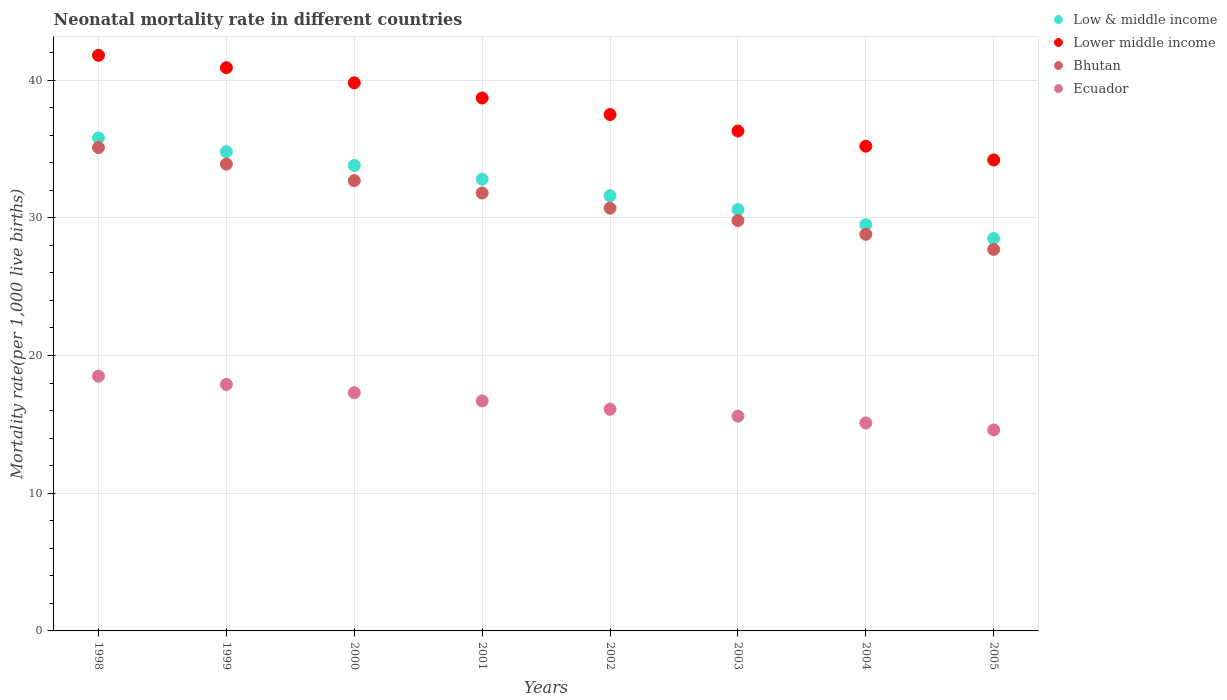Is the number of dotlines equal to the number of legend labels?
Offer a very short reply. Yes. Across all years, what is the maximum neonatal mortality rate in Low & middle income?
Provide a short and direct response. 35.8. In which year was the neonatal mortality rate in Low & middle income minimum?
Your answer should be very brief. 2005. What is the total neonatal mortality rate in Bhutan in the graph?
Provide a short and direct response. 250.5. What is the difference between the neonatal mortality rate in Bhutan in 1998 and that in 1999?
Offer a very short reply. 1.2. What is the difference between the neonatal mortality rate in Bhutan in 2000 and the neonatal mortality rate in Ecuador in 2005?
Keep it short and to the point. 18.1. What is the average neonatal mortality rate in Bhutan per year?
Provide a short and direct response. 31.31. In the year 2004, what is the difference between the neonatal mortality rate in Bhutan and neonatal mortality rate in Ecuador?
Your answer should be compact. 13.7. What is the ratio of the neonatal mortality rate in Bhutan in 1998 to that in 2003?
Offer a terse response. 1.18. What is the difference between the highest and the second highest neonatal mortality rate in Bhutan?
Give a very brief answer. 1.2. What is the difference between the highest and the lowest neonatal mortality rate in Bhutan?
Offer a very short reply. 7.4. In how many years, is the neonatal mortality rate in Ecuador greater than the average neonatal mortality rate in Ecuador taken over all years?
Keep it short and to the point. 4. Is the sum of the neonatal mortality rate in Lower middle income in 2000 and 2004 greater than the maximum neonatal mortality rate in Bhutan across all years?
Your answer should be compact. Yes. Is it the case that in every year, the sum of the neonatal mortality rate in Lower middle income and neonatal mortality rate in Ecuador  is greater than the sum of neonatal mortality rate in Low & middle income and neonatal mortality rate in Bhutan?
Ensure brevity in your answer.  Yes. Is the neonatal mortality rate in Ecuador strictly greater than the neonatal mortality rate in Low & middle income over the years?
Give a very brief answer. No. How many years are there in the graph?
Your response must be concise. 8. What is the difference between two consecutive major ticks on the Y-axis?
Your answer should be compact. 10. Are the values on the major ticks of Y-axis written in scientific E-notation?
Offer a very short reply. No. Does the graph contain grids?
Your answer should be very brief. Yes. Where does the legend appear in the graph?
Keep it short and to the point. Top right. How are the legend labels stacked?
Offer a terse response. Vertical. What is the title of the graph?
Your response must be concise. Neonatal mortality rate in different countries. What is the label or title of the X-axis?
Provide a succinct answer. Years. What is the label or title of the Y-axis?
Your response must be concise. Mortality rate(per 1,0 live births). What is the Mortality rate(per 1,000 live births) of Low & middle income in 1998?
Provide a succinct answer. 35.8. What is the Mortality rate(per 1,000 live births) of Lower middle income in 1998?
Offer a terse response. 41.8. What is the Mortality rate(per 1,000 live births) in Bhutan in 1998?
Give a very brief answer. 35.1. What is the Mortality rate(per 1,000 live births) of Ecuador in 1998?
Provide a short and direct response. 18.5. What is the Mortality rate(per 1,000 live births) in Low & middle income in 1999?
Make the answer very short. 34.8. What is the Mortality rate(per 1,000 live births) of Lower middle income in 1999?
Offer a terse response. 40.9. What is the Mortality rate(per 1,000 live births) of Bhutan in 1999?
Your answer should be compact. 33.9. What is the Mortality rate(per 1,000 live births) of Low & middle income in 2000?
Offer a very short reply. 33.8. What is the Mortality rate(per 1,000 live births) in Lower middle income in 2000?
Ensure brevity in your answer.  39.8. What is the Mortality rate(per 1,000 live births) of Bhutan in 2000?
Give a very brief answer. 32.7. What is the Mortality rate(per 1,000 live births) in Ecuador in 2000?
Offer a very short reply. 17.3. What is the Mortality rate(per 1,000 live births) in Low & middle income in 2001?
Make the answer very short. 32.8. What is the Mortality rate(per 1,000 live births) in Lower middle income in 2001?
Make the answer very short. 38.7. What is the Mortality rate(per 1,000 live births) of Bhutan in 2001?
Your answer should be compact. 31.8. What is the Mortality rate(per 1,000 live births) in Low & middle income in 2002?
Give a very brief answer. 31.6. What is the Mortality rate(per 1,000 live births) of Lower middle income in 2002?
Provide a succinct answer. 37.5. What is the Mortality rate(per 1,000 live births) of Bhutan in 2002?
Provide a succinct answer. 30.7. What is the Mortality rate(per 1,000 live births) in Low & middle income in 2003?
Ensure brevity in your answer.  30.6. What is the Mortality rate(per 1,000 live births) in Lower middle income in 2003?
Offer a very short reply. 36.3. What is the Mortality rate(per 1,000 live births) of Bhutan in 2003?
Give a very brief answer. 29.8. What is the Mortality rate(per 1,000 live births) in Low & middle income in 2004?
Give a very brief answer. 29.5. What is the Mortality rate(per 1,000 live births) in Lower middle income in 2004?
Provide a short and direct response. 35.2. What is the Mortality rate(per 1,000 live births) of Bhutan in 2004?
Provide a short and direct response. 28.8. What is the Mortality rate(per 1,000 live births) in Ecuador in 2004?
Give a very brief answer. 15.1. What is the Mortality rate(per 1,000 live births) in Low & middle income in 2005?
Your response must be concise. 28.5. What is the Mortality rate(per 1,000 live births) of Lower middle income in 2005?
Keep it short and to the point. 34.2. What is the Mortality rate(per 1,000 live births) in Bhutan in 2005?
Offer a terse response. 27.7. Across all years, what is the maximum Mortality rate(per 1,000 live births) of Low & middle income?
Ensure brevity in your answer.  35.8. Across all years, what is the maximum Mortality rate(per 1,000 live births) in Lower middle income?
Keep it short and to the point. 41.8. Across all years, what is the maximum Mortality rate(per 1,000 live births) in Bhutan?
Your answer should be compact. 35.1. Across all years, what is the maximum Mortality rate(per 1,000 live births) of Ecuador?
Your response must be concise. 18.5. Across all years, what is the minimum Mortality rate(per 1,000 live births) in Low & middle income?
Your response must be concise. 28.5. Across all years, what is the minimum Mortality rate(per 1,000 live births) of Lower middle income?
Offer a very short reply. 34.2. Across all years, what is the minimum Mortality rate(per 1,000 live births) in Bhutan?
Give a very brief answer. 27.7. Across all years, what is the minimum Mortality rate(per 1,000 live births) of Ecuador?
Provide a succinct answer. 14.6. What is the total Mortality rate(per 1,000 live births) of Low & middle income in the graph?
Offer a terse response. 257.4. What is the total Mortality rate(per 1,000 live births) in Lower middle income in the graph?
Make the answer very short. 304.4. What is the total Mortality rate(per 1,000 live births) of Bhutan in the graph?
Your response must be concise. 250.5. What is the total Mortality rate(per 1,000 live births) of Ecuador in the graph?
Keep it short and to the point. 131.8. What is the difference between the Mortality rate(per 1,000 live births) in Low & middle income in 1998 and that in 1999?
Provide a short and direct response. 1. What is the difference between the Mortality rate(per 1,000 live births) of Bhutan in 1998 and that in 1999?
Keep it short and to the point. 1.2. What is the difference between the Mortality rate(per 1,000 live births) in Low & middle income in 1998 and that in 2000?
Keep it short and to the point. 2. What is the difference between the Mortality rate(per 1,000 live births) of Lower middle income in 1998 and that in 2000?
Your answer should be compact. 2. What is the difference between the Mortality rate(per 1,000 live births) in Ecuador in 1998 and that in 2000?
Keep it short and to the point. 1.2. What is the difference between the Mortality rate(per 1,000 live births) in Lower middle income in 1998 and that in 2001?
Offer a very short reply. 3.1. What is the difference between the Mortality rate(per 1,000 live births) of Bhutan in 1998 and that in 2002?
Make the answer very short. 4.4. What is the difference between the Mortality rate(per 1,000 live births) in Ecuador in 1998 and that in 2002?
Offer a terse response. 2.4. What is the difference between the Mortality rate(per 1,000 live births) of Low & middle income in 1998 and that in 2003?
Give a very brief answer. 5.2. What is the difference between the Mortality rate(per 1,000 live births) of Bhutan in 1998 and that in 2004?
Your answer should be compact. 6.3. What is the difference between the Mortality rate(per 1,000 live births) of Low & middle income in 1998 and that in 2005?
Your answer should be compact. 7.3. What is the difference between the Mortality rate(per 1,000 live births) of Ecuador in 1998 and that in 2005?
Keep it short and to the point. 3.9. What is the difference between the Mortality rate(per 1,000 live births) of Low & middle income in 1999 and that in 2000?
Provide a short and direct response. 1. What is the difference between the Mortality rate(per 1,000 live births) in Lower middle income in 1999 and that in 2000?
Make the answer very short. 1.1. What is the difference between the Mortality rate(per 1,000 live births) in Bhutan in 1999 and that in 2000?
Give a very brief answer. 1.2. What is the difference between the Mortality rate(per 1,000 live births) in Ecuador in 1999 and that in 2000?
Your answer should be very brief. 0.6. What is the difference between the Mortality rate(per 1,000 live births) of Lower middle income in 1999 and that in 2001?
Your answer should be compact. 2.2. What is the difference between the Mortality rate(per 1,000 live births) of Bhutan in 1999 and that in 2001?
Ensure brevity in your answer.  2.1. What is the difference between the Mortality rate(per 1,000 live births) in Ecuador in 1999 and that in 2002?
Provide a short and direct response. 1.8. What is the difference between the Mortality rate(per 1,000 live births) in Bhutan in 1999 and that in 2003?
Your answer should be very brief. 4.1. What is the difference between the Mortality rate(per 1,000 live births) of Low & middle income in 1999 and that in 2004?
Ensure brevity in your answer.  5.3. What is the difference between the Mortality rate(per 1,000 live births) of Lower middle income in 1999 and that in 2004?
Provide a short and direct response. 5.7. What is the difference between the Mortality rate(per 1,000 live births) in Ecuador in 1999 and that in 2004?
Provide a short and direct response. 2.8. What is the difference between the Mortality rate(per 1,000 live births) of Lower middle income in 1999 and that in 2005?
Your answer should be compact. 6.7. What is the difference between the Mortality rate(per 1,000 live births) in Bhutan in 1999 and that in 2005?
Give a very brief answer. 6.2. What is the difference between the Mortality rate(per 1,000 live births) of Low & middle income in 2000 and that in 2001?
Offer a terse response. 1. What is the difference between the Mortality rate(per 1,000 live births) in Lower middle income in 2000 and that in 2001?
Provide a succinct answer. 1.1. What is the difference between the Mortality rate(per 1,000 live births) in Ecuador in 2000 and that in 2001?
Offer a very short reply. 0.6. What is the difference between the Mortality rate(per 1,000 live births) of Lower middle income in 2000 and that in 2002?
Provide a succinct answer. 2.3. What is the difference between the Mortality rate(per 1,000 live births) in Lower middle income in 2000 and that in 2003?
Your answer should be very brief. 3.5. What is the difference between the Mortality rate(per 1,000 live births) in Bhutan in 2000 and that in 2003?
Your answer should be compact. 2.9. What is the difference between the Mortality rate(per 1,000 live births) in Low & middle income in 2000 and that in 2004?
Make the answer very short. 4.3. What is the difference between the Mortality rate(per 1,000 live births) of Ecuador in 2000 and that in 2004?
Your answer should be compact. 2.2. What is the difference between the Mortality rate(per 1,000 live births) in Lower middle income in 2000 and that in 2005?
Ensure brevity in your answer.  5.6. What is the difference between the Mortality rate(per 1,000 live births) of Bhutan in 2000 and that in 2005?
Offer a very short reply. 5. What is the difference between the Mortality rate(per 1,000 live births) in Ecuador in 2000 and that in 2005?
Your answer should be compact. 2.7. What is the difference between the Mortality rate(per 1,000 live births) of Low & middle income in 2001 and that in 2002?
Ensure brevity in your answer.  1.2. What is the difference between the Mortality rate(per 1,000 live births) of Bhutan in 2001 and that in 2002?
Give a very brief answer. 1.1. What is the difference between the Mortality rate(per 1,000 live births) of Low & middle income in 2001 and that in 2003?
Make the answer very short. 2.2. What is the difference between the Mortality rate(per 1,000 live births) of Lower middle income in 2001 and that in 2003?
Provide a short and direct response. 2.4. What is the difference between the Mortality rate(per 1,000 live births) of Ecuador in 2001 and that in 2003?
Make the answer very short. 1.1. What is the difference between the Mortality rate(per 1,000 live births) of Low & middle income in 2001 and that in 2004?
Your answer should be compact. 3.3. What is the difference between the Mortality rate(per 1,000 live births) of Bhutan in 2001 and that in 2004?
Make the answer very short. 3. What is the difference between the Mortality rate(per 1,000 live births) in Ecuador in 2001 and that in 2004?
Make the answer very short. 1.6. What is the difference between the Mortality rate(per 1,000 live births) in Ecuador in 2001 and that in 2005?
Provide a short and direct response. 2.1. What is the difference between the Mortality rate(per 1,000 live births) of Lower middle income in 2002 and that in 2003?
Make the answer very short. 1.2. What is the difference between the Mortality rate(per 1,000 live births) in Bhutan in 2002 and that in 2003?
Give a very brief answer. 0.9. What is the difference between the Mortality rate(per 1,000 live births) in Ecuador in 2002 and that in 2003?
Ensure brevity in your answer.  0.5. What is the difference between the Mortality rate(per 1,000 live births) in Ecuador in 2002 and that in 2004?
Provide a succinct answer. 1. What is the difference between the Mortality rate(per 1,000 live births) of Low & middle income in 2002 and that in 2005?
Provide a short and direct response. 3.1. What is the difference between the Mortality rate(per 1,000 live births) in Lower middle income in 2002 and that in 2005?
Your answer should be compact. 3.3. What is the difference between the Mortality rate(per 1,000 live births) of Lower middle income in 2003 and that in 2004?
Offer a terse response. 1.1. What is the difference between the Mortality rate(per 1,000 live births) in Ecuador in 2003 and that in 2004?
Your response must be concise. 0.5. What is the difference between the Mortality rate(per 1,000 live births) in Lower middle income in 2003 and that in 2005?
Provide a succinct answer. 2.1. What is the difference between the Mortality rate(per 1,000 live births) of Bhutan in 2003 and that in 2005?
Offer a terse response. 2.1. What is the difference between the Mortality rate(per 1,000 live births) in Bhutan in 2004 and that in 2005?
Provide a succinct answer. 1.1. What is the difference between the Mortality rate(per 1,000 live births) of Ecuador in 2004 and that in 2005?
Your response must be concise. 0.5. What is the difference between the Mortality rate(per 1,000 live births) in Low & middle income in 1998 and the Mortality rate(per 1,000 live births) in Lower middle income in 1999?
Your answer should be compact. -5.1. What is the difference between the Mortality rate(per 1,000 live births) in Low & middle income in 1998 and the Mortality rate(per 1,000 live births) in Ecuador in 1999?
Provide a short and direct response. 17.9. What is the difference between the Mortality rate(per 1,000 live births) of Lower middle income in 1998 and the Mortality rate(per 1,000 live births) of Ecuador in 1999?
Your response must be concise. 23.9. What is the difference between the Mortality rate(per 1,000 live births) in Lower middle income in 1998 and the Mortality rate(per 1,000 live births) in Bhutan in 2000?
Provide a succinct answer. 9.1. What is the difference between the Mortality rate(per 1,000 live births) in Bhutan in 1998 and the Mortality rate(per 1,000 live births) in Ecuador in 2000?
Provide a succinct answer. 17.8. What is the difference between the Mortality rate(per 1,000 live births) in Lower middle income in 1998 and the Mortality rate(per 1,000 live births) in Ecuador in 2001?
Offer a very short reply. 25.1. What is the difference between the Mortality rate(per 1,000 live births) in Low & middle income in 1998 and the Mortality rate(per 1,000 live births) in Lower middle income in 2002?
Ensure brevity in your answer.  -1.7. What is the difference between the Mortality rate(per 1,000 live births) of Low & middle income in 1998 and the Mortality rate(per 1,000 live births) of Bhutan in 2002?
Make the answer very short. 5.1. What is the difference between the Mortality rate(per 1,000 live births) of Low & middle income in 1998 and the Mortality rate(per 1,000 live births) of Ecuador in 2002?
Provide a short and direct response. 19.7. What is the difference between the Mortality rate(per 1,000 live births) of Lower middle income in 1998 and the Mortality rate(per 1,000 live births) of Bhutan in 2002?
Keep it short and to the point. 11.1. What is the difference between the Mortality rate(per 1,000 live births) of Lower middle income in 1998 and the Mortality rate(per 1,000 live births) of Ecuador in 2002?
Your answer should be compact. 25.7. What is the difference between the Mortality rate(per 1,000 live births) in Bhutan in 1998 and the Mortality rate(per 1,000 live births) in Ecuador in 2002?
Offer a terse response. 19. What is the difference between the Mortality rate(per 1,000 live births) of Low & middle income in 1998 and the Mortality rate(per 1,000 live births) of Ecuador in 2003?
Your response must be concise. 20.2. What is the difference between the Mortality rate(per 1,000 live births) in Lower middle income in 1998 and the Mortality rate(per 1,000 live births) in Ecuador in 2003?
Keep it short and to the point. 26.2. What is the difference between the Mortality rate(per 1,000 live births) in Bhutan in 1998 and the Mortality rate(per 1,000 live births) in Ecuador in 2003?
Offer a terse response. 19.5. What is the difference between the Mortality rate(per 1,000 live births) in Low & middle income in 1998 and the Mortality rate(per 1,000 live births) in Ecuador in 2004?
Offer a terse response. 20.7. What is the difference between the Mortality rate(per 1,000 live births) in Lower middle income in 1998 and the Mortality rate(per 1,000 live births) in Ecuador in 2004?
Your response must be concise. 26.7. What is the difference between the Mortality rate(per 1,000 live births) in Low & middle income in 1998 and the Mortality rate(per 1,000 live births) in Bhutan in 2005?
Offer a terse response. 8.1. What is the difference between the Mortality rate(per 1,000 live births) of Low & middle income in 1998 and the Mortality rate(per 1,000 live births) of Ecuador in 2005?
Give a very brief answer. 21.2. What is the difference between the Mortality rate(per 1,000 live births) of Lower middle income in 1998 and the Mortality rate(per 1,000 live births) of Ecuador in 2005?
Offer a terse response. 27.2. What is the difference between the Mortality rate(per 1,000 live births) in Bhutan in 1998 and the Mortality rate(per 1,000 live births) in Ecuador in 2005?
Offer a terse response. 20.5. What is the difference between the Mortality rate(per 1,000 live births) in Low & middle income in 1999 and the Mortality rate(per 1,000 live births) in Lower middle income in 2000?
Your answer should be very brief. -5. What is the difference between the Mortality rate(per 1,000 live births) of Lower middle income in 1999 and the Mortality rate(per 1,000 live births) of Bhutan in 2000?
Make the answer very short. 8.2. What is the difference between the Mortality rate(per 1,000 live births) in Lower middle income in 1999 and the Mortality rate(per 1,000 live births) in Ecuador in 2000?
Your answer should be compact. 23.6. What is the difference between the Mortality rate(per 1,000 live births) in Bhutan in 1999 and the Mortality rate(per 1,000 live births) in Ecuador in 2000?
Ensure brevity in your answer.  16.6. What is the difference between the Mortality rate(per 1,000 live births) in Low & middle income in 1999 and the Mortality rate(per 1,000 live births) in Lower middle income in 2001?
Provide a succinct answer. -3.9. What is the difference between the Mortality rate(per 1,000 live births) of Low & middle income in 1999 and the Mortality rate(per 1,000 live births) of Bhutan in 2001?
Make the answer very short. 3. What is the difference between the Mortality rate(per 1,000 live births) of Low & middle income in 1999 and the Mortality rate(per 1,000 live births) of Ecuador in 2001?
Provide a short and direct response. 18.1. What is the difference between the Mortality rate(per 1,000 live births) in Lower middle income in 1999 and the Mortality rate(per 1,000 live births) in Ecuador in 2001?
Make the answer very short. 24.2. What is the difference between the Mortality rate(per 1,000 live births) in Low & middle income in 1999 and the Mortality rate(per 1,000 live births) in Lower middle income in 2002?
Your response must be concise. -2.7. What is the difference between the Mortality rate(per 1,000 live births) in Low & middle income in 1999 and the Mortality rate(per 1,000 live births) in Bhutan in 2002?
Your response must be concise. 4.1. What is the difference between the Mortality rate(per 1,000 live births) in Lower middle income in 1999 and the Mortality rate(per 1,000 live births) in Bhutan in 2002?
Your response must be concise. 10.2. What is the difference between the Mortality rate(per 1,000 live births) in Lower middle income in 1999 and the Mortality rate(per 1,000 live births) in Ecuador in 2002?
Offer a terse response. 24.8. What is the difference between the Mortality rate(per 1,000 live births) of Bhutan in 1999 and the Mortality rate(per 1,000 live births) of Ecuador in 2002?
Provide a short and direct response. 17.8. What is the difference between the Mortality rate(per 1,000 live births) of Lower middle income in 1999 and the Mortality rate(per 1,000 live births) of Bhutan in 2003?
Give a very brief answer. 11.1. What is the difference between the Mortality rate(per 1,000 live births) of Lower middle income in 1999 and the Mortality rate(per 1,000 live births) of Ecuador in 2003?
Your response must be concise. 25.3. What is the difference between the Mortality rate(per 1,000 live births) in Bhutan in 1999 and the Mortality rate(per 1,000 live births) in Ecuador in 2003?
Ensure brevity in your answer.  18.3. What is the difference between the Mortality rate(per 1,000 live births) of Low & middle income in 1999 and the Mortality rate(per 1,000 live births) of Lower middle income in 2004?
Ensure brevity in your answer.  -0.4. What is the difference between the Mortality rate(per 1,000 live births) of Low & middle income in 1999 and the Mortality rate(per 1,000 live births) of Ecuador in 2004?
Provide a succinct answer. 19.7. What is the difference between the Mortality rate(per 1,000 live births) of Lower middle income in 1999 and the Mortality rate(per 1,000 live births) of Bhutan in 2004?
Your response must be concise. 12.1. What is the difference between the Mortality rate(per 1,000 live births) in Lower middle income in 1999 and the Mortality rate(per 1,000 live births) in Ecuador in 2004?
Ensure brevity in your answer.  25.8. What is the difference between the Mortality rate(per 1,000 live births) of Low & middle income in 1999 and the Mortality rate(per 1,000 live births) of Bhutan in 2005?
Make the answer very short. 7.1. What is the difference between the Mortality rate(per 1,000 live births) of Low & middle income in 1999 and the Mortality rate(per 1,000 live births) of Ecuador in 2005?
Offer a terse response. 20.2. What is the difference between the Mortality rate(per 1,000 live births) in Lower middle income in 1999 and the Mortality rate(per 1,000 live births) in Bhutan in 2005?
Offer a terse response. 13.2. What is the difference between the Mortality rate(per 1,000 live births) of Lower middle income in 1999 and the Mortality rate(per 1,000 live births) of Ecuador in 2005?
Offer a terse response. 26.3. What is the difference between the Mortality rate(per 1,000 live births) of Bhutan in 1999 and the Mortality rate(per 1,000 live births) of Ecuador in 2005?
Offer a terse response. 19.3. What is the difference between the Mortality rate(per 1,000 live births) of Low & middle income in 2000 and the Mortality rate(per 1,000 live births) of Bhutan in 2001?
Your answer should be very brief. 2. What is the difference between the Mortality rate(per 1,000 live births) of Low & middle income in 2000 and the Mortality rate(per 1,000 live births) of Ecuador in 2001?
Make the answer very short. 17.1. What is the difference between the Mortality rate(per 1,000 live births) in Lower middle income in 2000 and the Mortality rate(per 1,000 live births) in Ecuador in 2001?
Offer a terse response. 23.1. What is the difference between the Mortality rate(per 1,000 live births) of Low & middle income in 2000 and the Mortality rate(per 1,000 live births) of Lower middle income in 2002?
Make the answer very short. -3.7. What is the difference between the Mortality rate(per 1,000 live births) in Low & middle income in 2000 and the Mortality rate(per 1,000 live births) in Bhutan in 2002?
Offer a very short reply. 3.1. What is the difference between the Mortality rate(per 1,000 live births) in Lower middle income in 2000 and the Mortality rate(per 1,000 live births) in Ecuador in 2002?
Your answer should be compact. 23.7. What is the difference between the Mortality rate(per 1,000 live births) of Bhutan in 2000 and the Mortality rate(per 1,000 live births) of Ecuador in 2002?
Give a very brief answer. 16.6. What is the difference between the Mortality rate(per 1,000 live births) in Lower middle income in 2000 and the Mortality rate(per 1,000 live births) in Bhutan in 2003?
Offer a very short reply. 10. What is the difference between the Mortality rate(per 1,000 live births) in Lower middle income in 2000 and the Mortality rate(per 1,000 live births) in Ecuador in 2003?
Your answer should be very brief. 24.2. What is the difference between the Mortality rate(per 1,000 live births) in Low & middle income in 2000 and the Mortality rate(per 1,000 live births) in Bhutan in 2004?
Offer a terse response. 5. What is the difference between the Mortality rate(per 1,000 live births) in Lower middle income in 2000 and the Mortality rate(per 1,000 live births) in Ecuador in 2004?
Your answer should be compact. 24.7. What is the difference between the Mortality rate(per 1,000 live births) of Low & middle income in 2000 and the Mortality rate(per 1,000 live births) of Bhutan in 2005?
Make the answer very short. 6.1. What is the difference between the Mortality rate(per 1,000 live births) of Lower middle income in 2000 and the Mortality rate(per 1,000 live births) of Ecuador in 2005?
Offer a terse response. 25.2. What is the difference between the Mortality rate(per 1,000 live births) in Low & middle income in 2001 and the Mortality rate(per 1,000 live births) in Bhutan in 2002?
Make the answer very short. 2.1. What is the difference between the Mortality rate(per 1,000 live births) in Lower middle income in 2001 and the Mortality rate(per 1,000 live births) in Bhutan in 2002?
Your answer should be compact. 8. What is the difference between the Mortality rate(per 1,000 live births) in Lower middle income in 2001 and the Mortality rate(per 1,000 live births) in Ecuador in 2002?
Make the answer very short. 22.6. What is the difference between the Mortality rate(per 1,000 live births) of Bhutan in 2001 and the Mortality rate(per 1,000 live births) of Ecuador in 2002?
Make the answer very short. 15.7. What is the difference between the Mortality rate(per 1,000 live births) of Low & middle income in 2001 and the Mortality rate(per 1,000 live births) of Bhutan in 2003?
Your response must be concise. 3. What is the difference between the Mortality rate(per 1,000 live births) of Low & middle income in 2001 and the Mortality rate(per 1,000 live births) of Ecuador in 2003?
Keep it short and to the point. 17.2. What is the difference between the Mortality rate(per 1,000 live births) in Lower middle income in 2001 and the Mortality rate(per 1,000 live births) in Ecuador in 2003?
Ensure brevity in your answer.  23.1. What is the difference between the Mortality rate(per 1,000 live births) in Bhutan in 2001 and the Mortality rate(per 1,000 live births) in Ecuador in 2003?
Your answer should be very brief. 16.2. What is the difference between the Mortality rate(per 1,000 live births) in Low & middle income in 2001 and the Mortality rate(per 1,000 live births) in Lower middle income in 2004?
Offer a very short reply. -2.4. What is the difference between the Mortality rate(per 1,000 live births) in Low & middle income in 2001 and the Mortality rate(per 1,000 live births) in Ecuador in 2004?
Keep it short and to the point. 17.7. What is the difference between the Mortality rate(per 1,000 live births) in Lower middle income in 2001 and the Mortality rate(per 1,000 live births) in Ecuador in 2004?
Give a very brief answer. 23.6. What is the difference between the Mortality rate(per 1,000 live births) in Bhutan in 2001 and the Mortality rate(per 1,000 live births) in Ecuador in 2004?
Make the answer very short. 16.7. What is the difference between the Mortality rate(per 1,000 live births) in Low & middle income in 2001 and the Mortality rate(per 1,000 live births) in Lower middle income in 2005?
Keep it short and to the point. -1.4. What is the difference between the Mortality rate(per 1,000 live births) of Low & middle income in 2001 and the Mortality rate(per 1,000 live births) of Ecuador in 2005?
Give a very brief answer. 18.2. What is the difference between the Mortality rate(per 1,000 live births) of Lower middle income in 2001 and the Mortality rate(per 1,000 live births) of Ecuador in 2005?
Offer a very short reply. 24.1. What is the difference between the Mortality rate(per 1,000 live births) of Low & middle income in 2002 and the Mortality rate(per 1,000 live births) of Lower middle income in 2003?
Keep it short and to the point. -4.7. What is the difference between the Mortality rate(per 1,000 live births) in Low & middle income in 2002 and the Mortality rate(per 1,000 live births) in Bhutan in 2003?
Your answer should be compact. 1.8. What is the difference between the Mortality rate(per 1,000 live births) in Low & middle income in 2002 and the Mortality rate(per 1,000 live births) in Ecuador in 2003?
Make the answer very short. 16. What is the difference between the Mortality rate(per 1,000 live births) of Lower middle income in 2002 and the Mortality rate(per 1,000 live births) of Ecuador in 2003?
Keep it short and to the point. 21.9. What is the difference between the Mortality rate(per 1,000 live births) of Bhutan in 2002 and the Mortality rate(per 1,000 live births) of Ecuador in 2003?
Offer a terse response. 15.1. What is the difference between the Mortality rate(per 1,000 live births) in Low & middle income in 2002 and the Mortality rate(per 1,000 live births) in Bhutan in 2004?
Keep it short and to the point. 2.8. What is the difference between the Mortality rate(per 1,000 live births) in Low & middle income in 2002 and the Mortality rate(per 1,000 live births) in Ecuador in 2004?
Provide a succinct answer. 16.5. What is the difference between the Mortality rate(per 1,000 live births) of Lower middle income in 2002 and the Mortality rate(per 1,000 live births) of Ecuador in 2004?
Offer a very short reply. 22.4. What is the difference between the Mortality rate(per 1,000 live births) in Bhutan in 2002 and the Mortality rate(per 1,000 live births) in Ecuador in 2004?
Your response must be concise. 15.6. What is the difference between the Mortality rate(per 1,000 live births) of Low & middle income in 2002 and the Mortality rate(per 1,000 live births) of Bhutan in 2005?
Keep it short and to the point. 3.9. What is the difference between the Mortality rate(per 1,000 live births) of Lower middle income in 2002 and the Mortality rate(per 1,000 live births) of Bhutan in 2005?
Offer a very short reply. 9.8. What is the difference between the Mortality rate(per 1,000 live births) of Lower middle income in 2002 and the Mortality rate(per 1,000 live births) of Ecuador in 2005?
Ensure brevity in your answer.  22.9. What is the difference between the Mortality rate(per 1,000 live births) in Low & middle income in 2003 and the Mortality rate(per 1,000 live births) in Lower middle income in 2004?
Provide a succinct answer. -4.6. What is the difference between the Mortality rate(per 1,000 live births) of Low & middle income in 2003 and the Mortality rate(per 1,000 live births) of Bhutan in 2004?
Your answer should be compact. 1.8. What is the difference between the Mortality rate(per 1,000 live births) of Lower middle income in 2003 and the Mortality rate(per 1,000 live births) of Bhutan in 2004?
Ensure brevity in your answer.  7.5. What is the difference between the Mortality rate(per 1,000 live births) in Lower middle income in 2003 and the Mortality rate(per 1,000 live births) in Ecuador in 2004?
Offer a very short reply. 21.2. What is the difference between the Mortality rate(per 1,000 live births) of Bhutan in 2003 and the Mortality rate(per 1,000 live births) of Ecuador in 2004?
Provide a short and direct response. 14.7. What is the difference between the Mortality rate(per 1,000 live births) in Low & middle income in 2003 and the Mortality rate(per 1,000 live births) in Bhutan in 2005?
Provide a succinct answer. 2.9. What is the difference between the Mortality rate(per 1,000 live births) in Low & middle income in 2003 and the Mortality rate(per 1,000 live births) in Ecuador in 2005?
Your response must be concise. 16. What is the difference between the Mortality rate(per 1,000 live births) in Lower middle income in 2003 and the Mortality rate(per 1,000 live births) in Bhutan in 2005?
Provide a short and direct response. 8.6. What is the difference between the Mortality rate(per 1,000 live births) of Lower middle income in 2003 and the Mortality rate(per 1,000 live births) of Ecuador in 2005?
Make the answer very short. 21.7. What is the difference between the Mortality rate(per 1,000 live births) of Low & middle income in 2004 and the Mortality rate(per 1,000 live births) of Ecuador in 2005?
Your response must be concise. 14.9. What is the difference between the Mortality rate(per 1,000 live births) in Lower middle income in 2004 and the Mortality rate(per 1,000 live births) in Ecuador in 2005?
Give a very brief answer. 20.6. What is the difference between the Mortality rate(per 1,000 live births) in Bhutan in 2004 and the Mortality rate(per 1,000 live births) in Ecuador in 2005?
Ensure brevity in your answer.  14.2. What is the average Mortality rate(per 1,000 live births) of Low & middle income per year?
Keep it short and to the point. 32.17. What is the average Mortality rate(per 1,000 live births) of Lower middle income per year?
Your answer should be compact. 38.05. What is the average Mortality rate(per 1,000 live births) in Bhutan per year?
Provide a succinct answer. 31.31. What is the average Mortality rate(per 1,000 live births) in Ecuador per year?
Offer a terse response. 16.48. In the year 1998, what is the difference between the Mortality rate(per 1,000 live births) in Low & middle income and Mortality rate(per 1,000 live births) in Bhutan?
Your answer should be compact. 0.7. In the year 1998, what is the difference between the Mortality rate(per 1,000 live births) of Lower middle income and Mortality rate(per 1,000 live births) of Ecuador?
Your response must be concise. 23.3. In the year 1998, what is the difference between the Mortality rate(per 1,000 live births) in Bhutan and Mortality rate(per 1,000 live births) in Ecuador?
Keep it short and to the point. 16.6. In the year 1999, what is the difference between the Mortality rate(per 1,000 live births) of Low & middle income and Mortality rate(per 1,000 live births) of Lower middle income?
Make the answer very short. -6.1. In the year 1999, what is the difference between the Mortality rate(per 1,000 live births) in Low & middle income and Mortality rate(per 1,000 live births) in Ecuador?
Make the answer very short. 16.9. In the year 1999, what is the difference between the Mortality rate(per 1,000 live births) in Lower middle income and Mortality rate(per 1,000 live births) in Bhutan?
Make the answer very short. 7. In the year 1999, what is the difference between the Mortality rate(per 1,000 live births) of Bhutan and Mortality rate(per 1,000 live births) of Ecuador?
Your answer should be compact. 16. In the year 2000, what is the difference between the Mortality rate(per 1,000 live births) of Low & middle income and Mortality rate(per 1,000 live births) of Lower middle income?
Your answer should be very brief. -6. In the year 2000, what is the difference between the Mortality rate(per 1,000 live births) of Low & middle income and Mortality rate(per 1,000 live births) of Bhutan?
Ensure brevity in your answer.  1.1. In the year 2000, what is the difference between the Mortality rate(per 1,000 live births) of Low & middle income and Mortality rate(per 1,000 live births) of Ecuador?
Offer a terse response. 16.5. In the year 2000, what is the difference between the Mortality rate(per 1,000 live births) of Lower middle income and Mortality rate(per 1,000 live births) of Ecuador?
Your answer should be very brief. 22.5. In the year 2001, what is the difference between the Mortality rate(per 1,000 live births) in Low & middle income and Mortality rate(per 1,000 live births) in Lower middle income?
Make the answer very short. -5.9. In the year 2001, what is the difference between the Mortality rate(per 1,000 live births) in Low & middle income and Mortality rate(per 1,000 live births) in Ecuador?
Provide a short and direct response. 16.1. In the year 2001, what is the difference between the Mortality rate(per 1,000 live births) in Lower middle income and Mortality rate(per 1,000 live births) in Bhutan?
Your answer should be compact. 6.9. In the year 2001, what is the difference between the Mortality rate(per 1,000 live births) in Bhutan and Mortality rate(per 1,000 live births) in Ecuador?
Keep it short and to the point. 15.1. In the year 2002, what is the difference between the Mortality rate(per 1,000 live births) in Low & middle income and Mortality rate(per 1,000 live births) in Bhutan?
Provide a succinct answer. 0.9. In the year 2002, what is the difference between the Mortality rate(per 1,000 live births) of Lower middle income and Mortality rate(per 1,000 live births) of Bhutan?
Make the answer very short. 6.8. In the year 2002, what is the difference between the Mortality rate(per 1,000 live births) of Lower middle income and Mortality rate(per 1,000 live births) of Ecuador?
Your answer should be compact. 21.4. In the year 2003, what is the difference between the Mortality rate(per 1,000 live births) in Low & middle income and Mortality rate(per 1,000 live births) in Ecuador?
Provide a succinct answer. 15. In the year 2003, what is the difference between the Mortality rate(per 1,000 live births) in Lower middle income and Mortality rate(per 1,000 live births) in Ecuador?
Your answer should be compact. 20.7. In the year 2004, what is the difference between the Mortality rate(per 1,000 live births) in Low & middle income and Mortality rate(per 1,000 live births) in Lower middle income?
Offer a terse response. -5.7. In the year 2004, what is the difference between the Mortality rate(per 1,000 live births) of Low & middle income and Mortality rate(per 1,000 live births) of Ecuador?
Keep it short and to the point. 14.4. In the year 2004, what is the difference between the Mortality rate(per 1,000 live births) in Lower middle income and Mortality rate(per 1,000 live births) in Ecuador?
Give a very brief answer. 20.1. In the year 2005, what is the difference between the Mortality rate(per 1,000 live births) in Low & middle income and Mortality rate(per 1,000 live births) in Bhutan?
Provide a succinct answer. 0.8. In the year 2005, what is the difference between the Mortality rate(per 1,000 live births) in Lower middle income and Mortality rate(per 1,000 live births) in Ecuador?
Keep it short and to the point. 19.6. In the year 2005, what is the difference between the Mortality rate(per 1,000 live births) of Bhutan and Mortality rate(per 1,000 live births) of Ecuador?
Offer a terse response. 13.1. What is the ratio of the Mortality rate(per 1,000 live births) in Low & middle income in 1998 to that in 1999?
Your answer should be compact. 1.03. What is the ratio of the Mortality rate(per 1,000 live births) of Bhutan in 1998 to that in 1999?
Keep it short and to the point. 1.04. What is the ratio of the Mortality rate(per 1,000 live births) in Ecuador in 1998 to that in 1999?
Provide a short and direct response. 1.03. What is the ratio of the Mortality rate(per 1,000 live births) of Low & middle income in 1998 to that in 2000?
Provide a succinct answer. 1.06. What is the ratio of the Mortality rate(per 1,000 live births) of Lower middle income in 1998 to that in 2000?
Your response must be concise. 1.05. What is the ratio of the Mortality rate(per 1,000 live births) in Bhutan in 1998 to that in 2000?
Offer a terse response. 1.07. What is the ratio of the Mortality rate(per 1,000 live births) in Ecuador in 1998 to that in 2000?
Keep it short and to the point. 1.07. What is the ratio of the Mortality rate(per 1,000 live births) of Low & middle income in 1998 to that in 2001?
Ensure brevity in your answer.  1.09. What is the ratio of the Mortality rate(per 1,000 live births) in Lower middle income in 1998 to that in 2001?
Your response must be concise. 1.08. What is the ratio of the Mortality rate(per 1,000 live births) of Bhutan in 1998 to that in 2001?
Your answer should be compact. 1.1. What is the ratio of the Mortality rate(per 1,000 live births) in Ecuador in 1998 to that in 2001?
Your answer should be compact. 1.11. What is the ratio of the Mortality rate(per 1,000 live births) of Low & middle income in 1998 to that in 2002?
Ensure brevity in your answer.  1.13. What is the ratio of the Mortality rate(per 1,000 live births) in Lower middle income in 1998 to that in 2002?
Offer a very short reply. 1.11. What is the ratio of the Mortality rate(per 1,000 live births) of Bhutan in 1998 to that in 2002?
Your answer should be compact. 1.14. What is the ratio of the Mortality rate(per 1,000 live births) in Ecuador in 1998 to that in 2002?
Your answer should be very brief. 1.15. What is the ratio of the Mortality rate(per 1,000 live births) of Low & middle income in 1998 to that in 2003?
Provide a succinct answer. 1.17. What is the ratio of the Mortality rate(per 1,000 live births) in Lower middle income in 1998 to that in 2003?
Provide a succinct answer. 1.15. What is the ratio of the Mortality rate(per 1,000 live births) in Bhutan in 1998 to that in 2003?
Provide a succinct answer. 1.18. What is the ratio of the Mortality rate(per 1,000 live births) in Ecuador in 1998 to that in 2003?
Keep it short and to the point. 1.19. What is the ratio of the Mortality rate(per 1,000 live births) in Low & middle income in 1998 to that in 2004?
Keep it short and to the point. 1.21. What is the ratio of the Mortality rate(per 1,000 live births) in Lower middle income in 1998 to that in 2004?
Provide a short and direct response. 1.19. What is the ratio of the Mortality rate(per 1,000 live births) in Bhutan in 1998 to that in 2004?
Keep it short and to the point. 1.22. What is the ratio of the Mortality rate(per 1,000 live births) of Ecuador in 1998 to that in 2004?
Your answer should be compact. 1.23. What is the ratio of the Mortality rate(per 1,000 live births) of Low & middle income in 1998 to that in 2005?
Your response must be concise. 1.26. What is the ratio of the Mortality rate(per 1,000 live births) of Lower middle income in 1998 to that in 2005?
Offer a very short reply. 1.22. What is the ratio of the Mortality rate(per 1,000 live births) in Bhutan in 1998 to that in 2005?
Ensure brevity in your answer.  1.27. What is the ratio of the Mortality rate(per 1,000 live births) of Ecuador in 1998 to that in 2005?
Your answer should be very brief. 1.27. What is the ratio of the Mortality rate(per 1,000 live births) in Low & middle income in 1999 to that in 2000?
Your response must be concise. 1.03. What is the ratio of the Mortality rate(per 1,000 live births) of Lower middle income in 1999 to that in 2000?
Offer a terse response. 1.03. What is the ratio of the Mortality rate(per 1,000 live births) in Bhutan in 1999 to that in 2000?
Ensure brevity in your answer.  1.04. What is the ratio of the Mortality rate(per 1,000 live births) in Ecuador in 1999 to that in 2000?
Your response must be concise. 1.03. What is the ratio of the Mortality rate(per 1,000 live births) in Low & middle income in 1999 to that in 2001?
Ensure brevity in your answer.  1.06. What is the ratio of the Mortality rate(per 1,000 live births) of Lower middle income in 1999 to that in 2001?
Your response must be concise. 1.06. What is the ratio of the Mortality rate(per 1,000 live births) of Bhutan in 1999 to that in 2001?
Provide a succinct answer. 1.07. What is the ratio of the Mortality rate(per 1,000 live births) in Ecuador in 1999 to that in 2001?
Your response must be concise. 1.07. What is the ratio of the Mortality rate(per 1,000 live births) in Low & middle income in 1999 to that in 2002?
Give a very brief answer. 1.1. What is the ratio of the Mortality rate(per 1,000 live births) of Lower middle income in 1999 to that in 2002?
Keep it short and to the point. 1.09. What is the ratio of the Mortality rate(per 1,000 live births) of Bhutan in 1999 to that in 2002?
Provide a short and direct response. 1.1. What is the ratio of the Mortality rate(per 1,000 live births) of Ecuador in 1999 to that in 2002?
Provide a short and direct response. 1.11. What is the ratio of the Mortality rate(per 1,000 live births) of Low & middle income in 1999 to that in 2003?
Your response must be concise. 1.14. What is the ratio of the Mortality rate(per 1,000 live births) in Lower middle income in 1999 to that in 2003?
Provide a succinct answer. 1.13. What is the ratio of the Mortality rate(per 1,000 live births) in Bhutan in 1999 to that in 2003?
Keep it short and to the point. 1.14. What is the ratio of the Mortality rate(per 1,000 live births) in Ecuador in 1999 to that in 2003?
Give a very brief answer. 1.15. What is the ratio of the Mortality rate(per 1,000 live births) of Low & middle income in 1999 to that in 2004?
Provide a succinct answer. 1.18. What is the ratio of the Mortality rate(per 1,000 live births) in Lower middle income in 1999 to that in 2004?
Your response must be concise. 1.16. What is the ratio of the Mortality rate(per 1,000 live births) of Bhutan in 1999 to that in 2004?
Offer a terse response. 1.18. What is the ratio of the Mortality rate(per 1,000 live births) of Ecuador in 1999 to that in 2004?
Your response must be concise. 1.19. What is the ratio of the Mortality rate(per 1,000 live births) in Low & middle income in 1999 to that in 2005?
Give a very brief answer. 1.22. What is the ratio of the Mortality rate(per 1,000 live births) of Lower middle income in 1999 to that in 2005?
Keep it short and to the point. 1.2. What is the ratio of the Mortality rate(per 1,000 live births) of Bhutan in 1999 to that in 2005?
Your answer should be very brief. 1.22. What is the ratio of the Mortality rate(per 1,000 live births) in Ecuador in 1999 to that in 2005?
Keep it short and to the point. 1.23. What is the ratio of the Mortality rate(per 1,000 live births) in Low & middle income in 2000 to that in 2001?
Your answer should be compact. 1.03. What is the ratio of the Mortality rate(per 1,000 live births) in Lower middle income in 2000 to that in 2001?
Provide a short and direct response. 1.03. What is the ratio of the Mortality rate(per 1,000 live births) of Bhutan in 2000 to that in 2001?
Offer a very short reply. 1.03. What is the ratio of the Mortality rate(per 1,000 live births) in Ecuador in 2000 to that in 2001?
Ensure brevity in your answer.  1.04. What is the ratio of the Mortality rate(per 1,000 live births) of Low & middle income in 2000 to that in 2002?
Your answer should be very brief. 1.07. What is the ratio of the Mortality rate(per 1,000 live births) in Lower middle income in 2000 to that in 2002?
Give a very brief answer. 1.06. What is the ratio of the Mortality rate(per 1,000 live births) in Bhutan in 2000 to that in 2002?
Your answer should be compact. 1.07. What is the ratio of the Mortality rate(per 1,000 live births) of Ecuador in 2000 to that in 2002?
Give a very brief answer. 1.07. What is the ratio of the Mortality rate(per 1,000 live births) of Low & middle income in 2000 to that in 2003?
Make the answer very short. 1.1. What is the ratio of the Mortality rate(per 1,000 live births) of Lower middle income in 2000 to that in 2003?
Your response must be concise. 1.1. What is the ratio of the Mortality rate(per 1,000 live births) in Bhutan in 2000 to that in 2003?
Your answer should be very brief. 1.1. What is the ratio of the Mortality rate(per 1,000 live births) of Ecuador in 2000 to that in 2003?
Provide a short and direct response. 1.11. What is the ratio of the Mortality rate(per 1,000 live births) in Low & middle income in 2000 to that in 2004?
Your answer should be very brief. 1.15. What is the ratio of the Mortality rate(per 1,000 live births) in Lower middle income in 2000 to that in 2004?
Make the answer very short. 1.13. What is the ratio of the Mortality rate(per 1,000 live births) in Bhutan in 2000 to that in 2004?
Keep it short and to the point. 1.14. What is the ratio of the Mortality rate(per 1,000 live births) of Ecuador in 2000 to that in 2004?
Your response must be concise. 1.15. What is the ratio of the Mortality rate(per 1,000 live births) in Low & middle income in 2000 to that in 2005?
Your answer should be compact. 1.19. What is the ratio of the Mortality rate(per 1,000 live births) in Lower middle income in 2000 to that in 2005?
Your response must be concise. 1.16. What is the ratio of the Mortality rate(per 1,000 live births) of Bhutan in 2000 to that in 2005?
Your response must be concise. 1.18. What is the ratio of the Mortality rate(per 1,000 live births) of Ecuador in 2000 to that in 2005?
Provide a short and direct response. 1.18. What is the ratio of the Mortality rate(per 1,000 live births) in Low & middle income in 2001 to that in 2002?
Your response must be concise. 1.04. What is the ratio of the Mortality rate(per 1,000 live births) of Lower middle income in 2001 to that in 2002?
Keep it short and to the point. 1.03. What is the ratio of the Mortality rate(per 1,000 live births) of Bhutan in 2001 to that in 2002?
Give a very brief answer. 1.04. What is the ratio of the Mortality rate(per 1,000 live births) in Ecuador in 2001 to that in 2002?
Provide a short and direct response. 1.04. What is the ratio of the Mortality rate(per 1,000 live births) of Low & middle income in 2001 to that in 2003?
Your response must be concise. 1.07. What is the ratio of the Mortality rate(per 1,000 live births) of Lower middle income in 2001 to that in 2003?
Give a very brief answer. 1.07. What is the ratio of the Mortality rate(per 1,000 live births) in Bhutan in 2001 to that in 2003?
Keep it short and to the point. 1.07. What is the ratio of the Mortality rate(per 1,000 live births) of Ecuador in 2001 to that in 2003?
Give a very brief answer. 1.07. What is the ratio of the Mortality rate(per 1,000 live births) in Low & middle income in 2001 to that in 2004?
Give a very brief answer. 1.11. What is the ratio of the Mortality rate(per 1,000 live births) of Lower middle income in 2001 to that in 2004?
Offer a very short reply. 1.1. What is the ratio of the Mortality rate(per 1,000 live births) in Bhutan in 2001 to that in 2004?
Your answer should be compact. 1.1. What is the ratio of the Mortality rate(per 1,000 live births) of Ecuador in 2001 to that in 2004?
Your answer should be compact. 1.11. What is the ratio of the Mortality rate(per 1,000 live births) of Low & middle income in 2001 to that in 2005?
Offer a very short reply. 1.15. What is the ratio of the Mortality rate(per 1,000 live births) of Lower middle income in 2001 to that in 2005?
Your answer should be compact. 1.13. What is the ratio of the Mortality rate(per 1,000 live births) of Bhutan in 2001 to that in 2005?
Give a very brief answer. 1.15. What is the ratio of the Mortality rate(per 1,000 live births) in Ecuador in 2001 to that in 2005?
Provide a short and direct response. 1.14. What is the ratio of the Mortality rate(per 1,000 live births) in Low & middle income in 2002 to that in 2003?
Your answer should be very brief. 1.03. What is the ratio of the Mortality rate(per 1,000 live births) in Lower middle income in 2002 to that in 2003?
Your response must be concise. 1.03. What is the ratio of the Mortality rate(per 1,000 live births) in Bhutan in 2002 to that in 2003?
Offer a very short reply. 1.03. What is the ratio of the Mortality rate(per 1,000 live births) in Ecuador in 2002 to that in 2003?
Ensure brevity in your answer.  1.03. What is the ratio of the Mortality rate(per 1,000 live births) in Low & middle income in 2002 to that in 2004?
Your answer should be compact. 1.07. What is the ratio of the Mortality rate(per 1,000 live births) of Lower middle income in 2002 to that in 2004?
Your answer should be compact. 1.07. What is the ratio of the Mortality rate(per 1,000 live births) of Bhutan in 2002 to that in 2004?
Ensure brevity in your answer.  1.07. What is the ratio of the Mortality rate(per 1,000 live births) of Ecuador in 2002 to that in 2004?
Make the answer very short. 1.07. What is the ratio of the Mortality rate(per 1,000 live births) in Low & middle income in 2002 to that in 2005?
Give a very brief answer. 1.11. What is the ratio of the Mortality rate(per 1,000 live births) in Lower middle income in 2002 to that in 2005?
Your answer should be compact. 1.1. What is the ratio of the Mortality rate(per 1,000 live births) of Bhutan in 2002 to that in 2005?
Make the answer very short. 1.11. What is the ratio of the Mortality rate(per 1,000 live births) of Ecuador in 2002 to that in 2005?
Your answer should be very brief. 1.1. What is the ratio of the Mortality rate(per 1,000 live births) of Low & middle income in 2003 to that in 2004?
Offer a very short reply. 1.04. What is the ratio of the Mortality rate(per 1,000 live births) in Lower middle income in 2003 to that in 2004?
Offer a very short reply. 1.03. What is the ratio of the Mortality rate(per 1,000 live births) of Bhutan in 2003 to that in 2004?
Provide a short and direct response. 1.03. What is the ratio of the Mortality rate(per 1,000 live births) in Ecuador in 2003 to that in 2004?
Offer a very short reply. 1.03. What is the ratio of the Mortality rate(per 1,000 live births) in Low & middle income in 2003 to that in 2005?
Provide a short and direct response. 1.07. What is the ratio of the Mortality rate(per 1,000 live births) of Lower middle income in 2003 to that in 2005?
Offer a very short reply. 1.06. What is the ratio of the Mortality rate(per 1,000 live births) in Bhutan in 2003 to that in 2005?
Your response must be concise. 1.08. What is the ratio of the Mortality rate(per 1,000 live births) in Ecuador in 2003 to that in 2005?
Your response must be concise. 1.07. What is the ratio of the Mortality rate(per 1,000 live births) in Low & middle income in 2004 to that in 2005?
Give a very brief answer. 1.04. What is the ratio of the Mortality rate(per 1,000 live births) in Lower middle income in 2004 to that in 2005?
Provide a succinct answer. 1.03. What is the ratio of the Mortality rate(per 1,000 live births) of Bhutan in 2004 to that in 2005?
Make the answer very short. 1.04. What is the ratio of the Mortality rate(per 1,000 live births) in Ecuador in 2004 to that in 2005?
Provide a short and direct response. 1.03. What is the difference between the highest and the second highest Mortality rate(per 1,000 live births) in Low & middle income?
Make the answer very short. 1. What is the difference between the highest and the second highest Mortality rate(per 1,000 live births) of Bhutan?
Your answer should be very brief. 1.2. What is the difference between the highest and the second highest Mortality rate(per 1,000 live births) of Ecuador?
Your answer should be very brief. 0.6. What is the difference between the highest and the lowest Mortality rate(per 1,000 live births) of Lower middle income?
Offer a terse response. 7.6. What is the difference between the highest and the lowest Mortality rate(per 1,000 live births) of Bhutan?
Make the answer very short. 7.4. What is the difference between the highest and the lowest Mortality rate(per 1,000 live births) of Ecuador?
Offer a terse response. 3.9. 